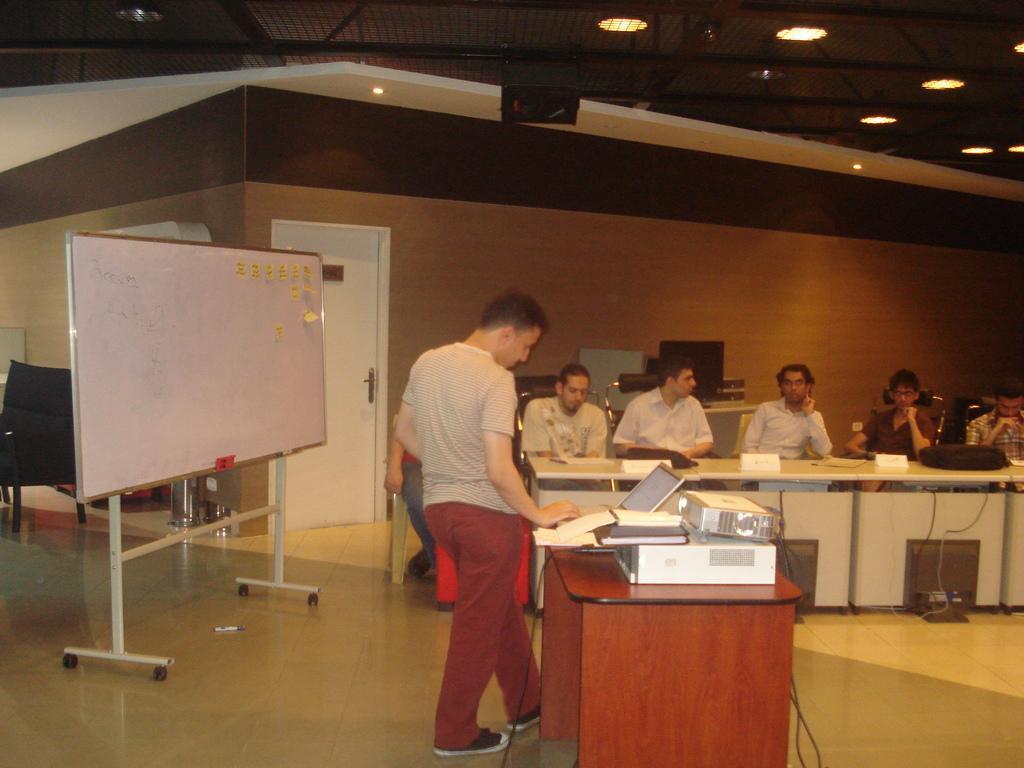Could you give a brief overview of what you see in this image? This image is clicked in a room. There are lights on the top. There are tables on the right side and there is a white board on the left side. There is a door on the left side, there are people sitting on chair near the tables. On the table is there are laptop, files, name boards, bags. 